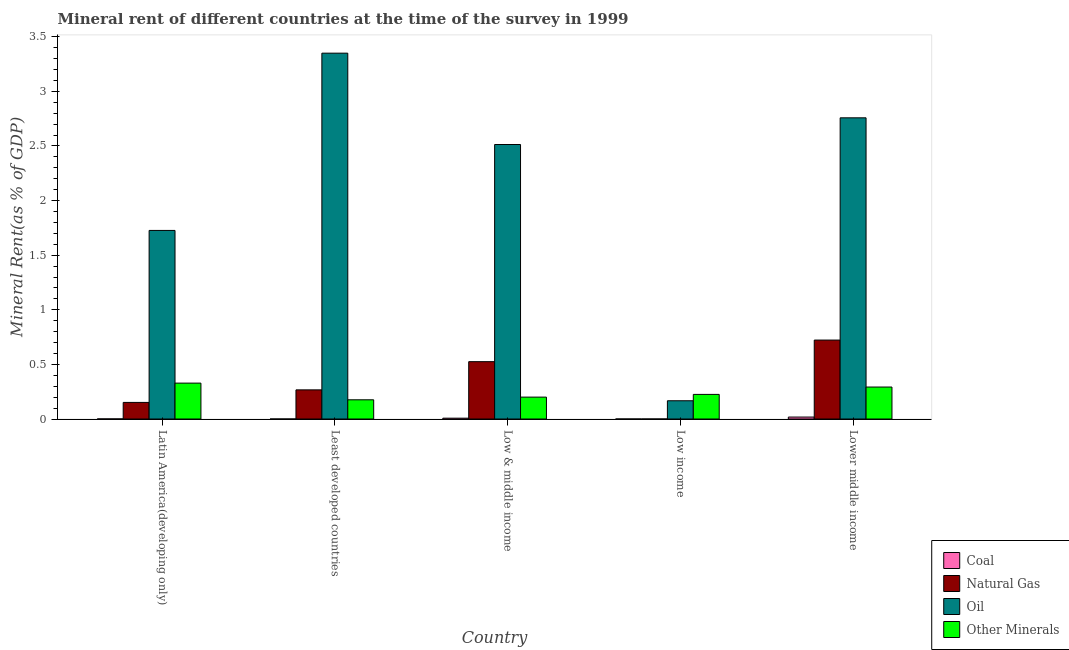How many bars are there on the 1st tick from the left?
Ensure brevity in your answer.  4. How many bars are there on the 4th tick from the right?
Offer a very short reply. 4. What is the label of the 1st group of bars from the left?
Keep it short and to the point. Latin America(developing only). What is the oil rent in Latin America(developing only)?
Your answer should be compact. 1.73. Across all countries, what is the maximum oil rent?
Ensure brevity in your answer.  3.35. Across all countries, what is the minimum oil rent?
Offer a very short reply. 0.17. In which country was the oil rent maximum?
Your answer should be compact. Least developed countries. In which country was the  rent of other minerals minimum?
Offer a terse response. Least developed countries. What is the total  rent of other minerals in the graph?
Your answer should be compact. 1.22. What is the difference between the natural gas rent in Latin America(developing only) and that in Low income?
Provide a succinct answer. 0.15. What is the difference between the  rent of other minerals in Lower middle income and the natural gas rent in Low & middle income?
Provide a short and direct response. -0.23. What is the average  rent of other minerals per country?
Make the answer very short. 0.24. What is the difference between the oil rent and natural gas rent in Latin America(developing only)?
Your answer should be very brief. 1.57. What is the ratio of the coal rent in Latin America(developing only) to that in Low income?
Make the answer very short. 89.33. Is the oil rent in Latin America(developing only) less than that in Low & middle income?
Make the answer very short. Yes. Is the difference between the coal rent in Least developed countries and Low & middle income greater than the difference between the oil rent in Least developed countries and Low & middle income?
Offer a very short reply. No. What is the difference between the highest and the second highest natural gas rent?
Ensure brevity in your answer.  0.2. What is the difference between the highest and the lowest  rent of other minerals?
Provide a short and direct response. 0.15. In how many countries, is the coal rent greater than the average coal rent taken over all countries?
Provide a short and direct response. 2. Is it the case that in every country, the sum of the oil rent and coal rent is greater than the sum of  rent of other minerals and natural gas rent?
Your answer should be very brief. No. What does the 1st bar from the left in Low & middle income represents?
Your answer should be very brief. Coal. What does the 1st bar from the right in Lower middle income represents?
Your answer should be compact. Other Minerals. How many bars are there?
Provide a short and direct response. 20. Are all the bars in the graph horizontal?
Make the answer very short. No. Does the graph contain any zero values?
Provide a short and direct response. No. Does the graph contain grids?
Ensure brevity in your answer.  No. Where does the legend appear in the graph?
Give a very brief answer. Bottom right. How many legend labels are there?
Offer a terse response. 4. How are the legend labels stacked?
Your response must be concise. Vertical. What is the title of the graph?
Your answer should be compact. Mineral rent of different countries at the time of the survey in 1999. What is the label or title of the Y-axis?
Your answer should be compact. Mineral Rent(as % of GDP). What is the Mineral Rent(as % of GDP) of Coal in Latin America(developing only)?
Offer a terse response. 0. What is the Mineral Rent(as % of GDP) of Natural Gas in Latin America(developing only)?
Your answer should be compact. 0.15. What is the Mineral Rent(as % of GDP) in Oil in Latin America(developing only)?
Your response must be concise. 1.73. What is the Mineral Rent(as % of GDP) of Other Minerals in Latin America(developing only)?
Provide a short and direct response. 0.33. What is the Mineral Rent(as % of GDP) in Coal in Least developed countries?
Provide a short and direct response. 1.688733010769859e-5. What is the Mineral Rent(as % of GDP) in Natural Gas in Least developed countries?
Offer a very short reply. 0.27. What is the Mineral Rent(as % of GDP) of Oil in Least developed countries?
Your response must be concise. 3.35. What is the Mineral Rent(as % of GDP) in Other Minerals in Least developed countries?
Your answer should be compact. 0.18. What is the Mineral Rent(as % of GDP) of Coal in Low & middle income?
Provide a succinct answer. 0.01. What is the Mineral Rent(as % of GDP) of Natural Gas in Low & middle income?
Keep it short and to the point. 0.53. What is the Mineral Rent(as % of GDP) in Oil in Low & middle income?
Your answer should be compact. 2.51. What is the Mineral Rent(as % of GDP) in Other Minerals in Low & middle income?
Offer a terse response. 0.2. What is the Mineral Rent(as % of GDP) in Coal in Low income?
Ensure brevity in your answer.  9.01283239610206e-6. What is the Mineral Rent(as % of GDP) of Natural Gas in Low income?
Offer a very short reply. 4.69772614176007e-5. What is the Mineral Rent(as % of GDP) in Oil in Low income?
Make the answer very short. 0.17. What is the Mineral Rent(as % of GDP) in Other Minerals in Low income?
Provide a succinct answer. 0.23. What is the Mineral Rent(as % of GDP) of Coal in Lower middle income?
Make the answer very short. 0.02. What is the Mineral Rent(as % of GDP) of Natural Gas in Lower middle income?
Ensure brevity in your answer.  0.72. What is the Mineral Rent(as % of GDP) in Oil in Lower middle income?
Your response must be concise. 2.76. What is the Mineral Rent(as % of GDP) in Other Minerals in Lower middle income?
Your response must be concise. 0.29. Across all countries, what is the maximum Mineral Rent(as % of GDP) of Coal?
Ensure brevity in your answer.  0.02. Across all countries, what is the maximum Mineral Rent(as % of GDP) of Natural Gas?
Offer a terse response. 0.72. Across all countries, what is the maximum Mineral Rent(as % of GDP) in Oil?
Your answer should be very brief. 3.35. Across all countries, what is the maximum Mineral Rent(as % of GDP) in Other Minerals?
Give a very brief answer. 0.33. Across all countries, what is the minimum Mineral Rent(as % of GDP) of Coal?
Give a very brief answer. 9.01283239610206e-6. Across all countries, what is the minimum Mineral Rent(as % of GDP) of Natural Gas?
Offer a very short reply. 4.69772614176007e-5. Across all countries, what is the minimum Mineral Rent(as % of GDP) of Oil?
Make the answer very short. 0.17. Across all countries, what is the minimum Mineral Rent(as % of GDP) in Other Minerals?
Offer a terse response. 0.18. What is the total Mineral Rent(as % of GDP) of Coal in the graph?
Keep it short and to the point. 0.03. What is the total Mineral Rent(as % of GDP) of Natural Gas in the graph?
Provide a succinct answer. 1.67. What is the total Mineral Rent(as % of GDP) of Oil in the graph?
Offer a terse response. 10.51. What is the total Mineral Rent(as % of GDP) of Other Minerals in the graph?
Your answer should be very brief. 1.22. What is the difference between the Mineral Rent(as % of GDP) in Coal in Latin America(developing only) and that in Least developed countries?
Provide a succinct answer. 0. What is the difference between the Mineral Rent(as % of GDP) in Natural Gas in Latin America(developing only) and that in Least developed countries?
Ensure brevity in your answer.  -0.11. What is the difference between the Mineral Rent(as % of GDP) in Oil in Latin America(developing only) and that in Least developed countries?
Provide a short and direct response. -1.62. What is the difference between the Mineral Rent(as % of GDP) in Other Minerals in Latin America(developing only) and that in Least developed countries?
Your response must be concise. 0.15. What is the difference between the Mineral Rent(as % of GDP) of Coal in Latin America(developing only) and that in Low & middle income?
Ensure brevity in your answer.  -0.01. What is the difference between the Mineral Rent(as % of GDP) in Natural Gas in Latin America(developing only) and that in Low & middle income?
Your response must be concise. -0.37. What is the difference between the Mineral Rent(as % of GDP) of Oil in Latin America(developing only) and that in Low & middle income?
Your answer should be very brief. -0.79. What is the difference between the Mineral Rent(as % of GDP) of Other Minerals in Latin America(developing only) and that in Low & middle income?
Offer a terse response. 0.13. What is the difference between the Mineral Rent(as % of GDP) in Coal in Latin America(developing only) and that in Low income?
Your answer should be very brief. 0. What is the difference between the Mineral Rent(as % of GDP) of Natural Gas in Latin America(developing only) and that in Low income?
Keep it short and to the point. 0.15. What is the difference between the Mineral Rent(as % of GDP) of Oil in Latin America(developing only) and that in Low income?
Make the answer very short. 1.56. What is the difference between the Mineral Rent(as % of GDP) in Other Minerals in Latin America(developing only) and that in Low income?
Offer a very short reply. 0.1. What is the difference between the Mineral Rent(as % of GDP) in Coal in Latin America(developing only) and that in Lower middle income?
Your answer should be very brief. -0.02. What is the difference between the Mineral Rent(as % of GDP) in Natural Gas in Latin America(developing only) and that in Lower middle income?
Offer a very short reply. -0.57. What is the difference between the Mineral Rent(as % of GDP) in Oil in Latin America(developing only) and that in Lower middle income?
Your response must be concise. -1.03. What is the difference between the Mineral Rent(as % of GDP) in Other Minerals in Latin America(developing only) and that in Lower middle income?
Give a very brief answer. 0.04. What is the difference between the Mineral Rent(as % of GDP) in Coal in Least developed countries and that in Low & middle income?
Keep it short and to the point. -0.01. What is the difference between the Mineral Rent(as % of GDP) in Natural Gas in Least developed countries and that in Low & middle income?
Give a very brief answer. -0.26. What is the difference between the Mineral Rent(as % of GDP) of Oil in Least developed countries and that in Low & middle income?
Provide a succinct answer. 0.84. What is the difference between the Mineral Rent(as % of GDP) of Other Minerals in Least developed countries and that in Low & middle income?
Your answer should be very brief. -0.02. What is the difference between the Mineral Rent(as % of GDP) in Natural Gas in Least developed countries and that in Low income?
Provide a succinct answer. 0.27. What is the difference between the Mineral Rent(as % of GDP) of Oil in Least developed countries and that in Low income?
Offer a terse response. 3.18. What is the difference between the Mineral Rent(as % of GDP) of Other Minerals in Least developed countries and that in Low income?
Provide a succinct answer. -0.05. What is the difference between the Mineral Rent(as % of GDP) of Coal in Least developed countries and that in Lower middle income?
Make the answer very short. -0.02. What is the difference between the Mineral Rent(as % of GDP) of Natural Gas in Least developed countries and that in Lower middle income?
Ensure brevity in your answer.  -0.46. What is the difference between the Mineral Rent(as % of GDP) in Oil in Least developed countries and that in Lower middle income?
Your response must be concise. 0.59. What is the difference between the Mineral Rent(as % of GDP) of Other Minerals in Least developed countries and that in Lower middle income?
Provide a succinct answer. -0.12. What is the difference between the Mineral Rent(as % of GDP) of Coal in Low & middle income and that in Low income?
Ensure brevity in your answer.  0.01. What is the difference between the Mineral Rent(as % of GDP) of Natural Gas in Low & middle income and that in Low income?
Give a very brief answer. 0.53. What is the difference between the Mineral Rent(as % of GDP) in Oil in Low & middle income and that in Low income?
Your answer should be compact. 2.35. What is the difference between the Mineral Rent(as % of GDP) of Other Minerals in Low & middle income and that in Low income?
Your response must be concise. -0.02. What is the difference between the Mineral Rent(as % of GDP) in Coal in Low & middle income and that in Lower middle income?
Make the answer very short. -0.01. What is the difference between the Mineral Rent(as % of GDP) in Natural Gas in Low & middle income and that in Lower middle income?
Provide a succinct answer. -0.2. What is the difference between the Mineral Rent(as % of GDP) in Oil in Low & middle income and that in Lower middle income?
Provide a short and direct response. -0.24. What is the difference between the Mineral Rent(as % of GDP) of Other Minerals in Low & middle income and that in Lower middle income?
Your response must be concise. -0.09. What is the difference between the Mineral Rent(as % of GDP) of Coal in Low income and that in Lower middle income?
Keep it short and to the point. -0.02. What is the difference between the Mineral Rent(as % of GDP) of Natural Gas in Low income and that in Lower middle income?
Ensure brevity in your answer.  -0.72. What is the difference between the Mineral Rent(as % of GDP) of Oil in Low income and that in Lower middle income?
Provide a short and direct response. -2.59. What is the difference between the Mineral Rent(as % of GDP) of Other Minerals in Low income and that in Lower middle income?
Keep it short and to the point. -0.07. What is the difference between the Mineral Rent(as % of GDP) of Coal in Latin America(developing only) and the Mineral Rent(as % of GDP) of Natural Gas in Least developed countries?
Provide a short and direct response. -0.27. What is the difference between the Mineral Rent(as % of GDP) of Coal in Latin America(developing only) and the Mineral Rent(as % of GDP) of Oil in Least developed countries?
Ensure brevity in your answer.  -3.35. What is the difference between the Mineral Rent(as % of GDP) of Coal in Latin America(developing only) and the Mineral Rent(as % of GDP) of Other Minerals in Least developed countries?
Provide a short and direct response. -0.18. What is the difference between the Mineral Rent(as % of GDP) in Natural Gas in Latin America(developing only) and the Mineral Rent(as % of GDP) in Oil in Least developed countries?
Your response must be concise. -3.2. What is the difference between the Mineral Rent(as % of GDP) in Natural Gas in Latin America(developing only) and the Mineral Rent(as % of GDP) in Other Minerals in Least developed countries?
Offer a very short reply. -0.02. What is the difference between the Mineral Rent(as % of GDP) of Oil in Latin America(developing only) and the Mineral Rent(as % of GDP) of Other Minerals in Least developed countries?
Ensure brevity in your answer.  1.55. What is the difference between the Mineral Rent(as % of GDP) in Coal in Latin America(developing only) and the Mineral Rent(as % of GDP) in Natural Gas in Low & middle income?
Keep it short and to the point. -0.52. What is the difference between the Mineral Rent(as % of GDP) of Coal in Latin America(developing only) and the Mineral Rent(as % of GDP) of Oil in Low & middle income?
Provide a succinct answer. -2.51. What is the difference between the Mineral Rent(as % of GDP) in Coal in Latin America(developing only) and the Mineral Rent(as % of GDP) in Other Minerals in Low & middle income?
Provide a succinct answer. -0.2. What is the difference between the Mineral Rent(as % of GDP) in Natural Gas in Latin America(developing only) and the Mineral Rent(as % of GDP) in Oil in Low & middle income?
Ensure brevity in your answer.  -2.36. What is the difference between the Mineral Rent(as % of GDP) in Natural Gas in Latin America(developing only) and the Mineral Rent(as % of GDP) in Other Minerals in Low & middle income?
Ensure brevity in your answer.  -0.05. What is the difference between the Mineral Rent(as % of GDP) in Oil in Latin America(developing only) and the Mineral Rent(as % of GDP) in Other Minerals in Low & middle income?
Your answer should be compact. 1.53. What is the difference between the Mineral Rent(as % of GDP) of Coal in Latin America(developing only) and the Mineral Rent(as % of GDP) of Natural Gas in Low income?
Offer a terse response. 0. What is the difference between the Mineral Rent(as % of GDP) of Coal in Latin America(developing only) and the Mineral Rent(as % of GDP) of Oil in Low income?
Make the answer very short. -0.17. What is the difference between the Mineral Rent(as % of GDP) of Coal in Latin America(developing only) and the Mineral Rent(as % of GDP) of Other Minerals in Low income?
Offer a terse response. -0.22. What is the difference between the Mineral Rent(as % of GDP) in Natural Gas in Latin America(developing only) and the Mineral Rent(as % of GDP) in Oil in Low income?
Ensure brevity in your answer.  -0.02. What is the difference between the Mineral Rent(as % of GDP) in Natural Gas in Latin America(developing only) and the Mineral Rent(as % of GDP) in Other Minerals in Low income?
Your response must be concise. -0.07. What is the difference between the Mineral Rent(as % of GDP) in Oil in Latin America(developing only) and the Mineral Rent(as % of GDP) in Other Minerals in Low income?
Offer a terse response. 1.5. What is the difference between the Mineral Rent(as % of GDP) of Coal in Latin America(developing only) and the Mineral Rent(as % of GDP) of Natural Gas in Lower middle income?
Provide a short and direct response. -0.72. What is the difference between the Mineral Rent(as % of GDP) in Coal in Latin America(developing only) and the Mineral Rent(as % of GDP) in Oil in Lower middle income?
Ensure brevity in your answer.  -2.76. What is the difference between the Mineral Rent(as % of GDP) in Coal in Latin America(developing only) and the Mineral Rent(as % of GDP) in Other Minerals in Lower middle income?
Make the answer very short. -0.29. What is the difference between the Mineral Rent(as % of GDP) of Natural Gas in Latin America(developing only) and the Mineral Rent(as % of GDP) of Oil in Lower middle income?
Offer a terse response. -2.61. What is the difference between the Mineral Rent(as % of GDP) in Natural Gas in Latin America(developing only) and the Mineral Rent(as % of GDP) in Other Minerals in Lower middle income?
Offer a very short reply. -0.14. What is the difference between the Mineral Rent(as % of GDP) of Oil in Latin America(developing only) and the Mineral Rent(as % of GDP) of Other Minerals in Lower middle income?
Give a very brief answer. 1.43. What is the difference between the Mineral Rent(as % of GDP) in Coal in Least developed countries and the Mineral Rent(as % of GDP) in Natural Gas in Low & middle income?
Offer a terse response. -0.53. What is the difference between the Mineral Rent(as % of GDP) of Coal in Least developed countries and the Mineral Rent(as % of GDP) of Oil in Low & middle income?
Your answer should be compact. -2.51. What is the difference between the Mineral Rent(as % of GDP) of Coal in Least developed countries and the Mineral Rent(as % of GDP) of Other Minerals in Low & middle income?
Your answer should be compact. -0.2. What is the difference between the Mineral Rent(as % of GDP) in Natural Gas in Least developed countries and the Mineral Rent(as % of GDP) in Oil in Low & middle income?
Provide a short and direct response. -2.25. What is the difference between the Mineral Rent(as % of GDP) in Natural Gas in Least developed countries and the Mineral Rent(as % of GDP) in Other Minerals in Low & middle income?
Your answer should be very brief. 0.07. What is the difference between the Mineral Rent(as % of GDP) in Oil in Least developed countries and the Mineral Rent(as % of GDP) in Other Minerals in Low & middle income?
Ensure brevity in your answer.  3.15. What is the difference between the Mineral Rent(as % of GDP) of Coal in Least developed countries and the Mineral Rent(as % of GDP) of Oil in Low income?
Provide a succinct answer. -0.17. What is the difference between the Mineral Rent(as % of GDP) in Coal in Least developed countries and the Mineral Rent(as % of GDP) in Other Minerals in Low income?
Keep it short and to the point. -0.23. What is the difference between the Mineral Rent(as % of GDP) in Natural Gas in Least developed countries and the Mineral Rent(as % of GDP) in Oil in Low income?
Ensure brevity in your answer.  0.1. What is the difference between the Mineral Rent(as % of GDP) of Natural Gas in Least developed countries and the Mineral Rent(as % of GDP) of Other Minerals in Low income?
Offer a very short reply. 0.04. What is the difference between the Mineral Rent(as % of GDP) in Oil in Least developed countries and the Mineral Rent(as % of GDP) in Other Minerals in Low income?
Keep it short and to the point. 3.12. What is the difference between the Mineral Rent(as % of GDP) of Coal in Least developed countries and the Mineral Rent(as % of GDP) of Natural Gas in Lower middle income?
Keep it short and to the point. -0.72. What is the difference between the Mineral Rent(as % of GDP) in Coal in Least developed countries and the Mineral Rent(as % of GDP) in Oil in Lower middle income?
Keep it short and to the point. -2.76. What is the difference between the Mineral Rent(as % of GDP) of Coal in Least developed countries and the Mineral Rent(as % of GDP) of Other Minerals in Lower middle income?
Your answer should be very brief. -0.29. What is the difference between the Mineral Rent(as % of GDP) of Natural Gas in Least developed countries and the Mineral Rent(as % of GDP) of Oil in Lower middle income?
Give a very brief answer. -2.49. What is the difference between the Mineral Rent(as % of GDP) in Natural Gas in Least developed countries and the Mineral Rent(as % of GDP) in Other Minerals in Lower middle income?
Make the answer very short. -0.03. What is the difference between the Mineral Rent(as % of GDP) of Oil in Least developed countries and the Mineral Rent(as % of GDP) of Other Minerals in Lower middle income?
Your response must be concise. 3.06. What is the difference between the Mineral Rent(as % of GDP) in Coal in Low & middle income and the Mineral Rent(as % of GDP) in Natural Gas in Low income?
Give a very brief answer. 0.01. What is the difference between the Mineral Rent(as % of GDP) of Coal in Low & middle income and the Mineral Rent(as % of GDP) of Oil in Low income?
Your answer should be very brief. -0.16. What is the difference between the Mineral Rent(as % of GDP) in Coal in Low & middle income and the Mineral Rent(as % of GDP) in Other Minerals in Low income?
Your response must be concise. -0.22. What is the difference between the Mineral Rent(as % of GDP) of Natural Gas in Low & middle income and the Mineral Rent(as % of GDP) of Oil in Low income?
Give a very brief answer. 0.36. What is the difference between the Mineral Rent(as % of GDP) of Natural Gas in Low & middle income and the Mineral Rent(as % of GDP) of Other Minerals in Low income?
Offer a terse response. 0.3. What is the difference between the Mineral Rent(as % of GDP) of Oil in Low & middle income and the Mineral Rent(as % of GDP) of Other Minerals in Low income?
Provide a short and direct response. 2.29. What is the difference between the Mineral Rent(as % of GDP) of Coal in Low & middle income and the Mineral Rent(as % of GDP) of Natural Gas in Lower middle income?
Give a very brief answer. -0.72. What is the difference between the Mineral Rent(as % of GDP) of Coal in Low & middle income and the Mineral Rent(as % of GDP) of Oil in Lower middle income?
Your response must be concise. -2.75. What is the difference between the Mineral Rent(as % of GDP) of Coal in Low & middle income and the Mineral Rent(as % of GDP) of Other Minerals in Lower middle income?
Your response must be concise. -0.29. What is the difference between the Mineral Rent(as % of GDP) in Natural Gas in Low & middle income and the Mineral Rent(as % of GDP) in Oil in Lower middle income?
Offer a very short reply. -2.23. What is the difference between the Mineral Rent(as % of GDP) in Natural Gas in Low & middle income and the Mineral Rent(as % of GDP) in Other Minerals in Lower middle income?
Ensure brevity in your answer.  0.23. What is the difference between the Mineral Rent(as % of GDP) of Oil in Low & middle income and the Mineral Rent(as % of GDP) of Other Minerals in Lower middle income?
Provide a succinct answer. 2.22. What is the difference between the Mineral Rent(as % of GDP) in Coal in Low income and the Mineral Rent(as % of GDP) in Natural Gas in Lower middle income?
Your response must be concise. -0.72. What is the difference between the Mineral Rent(as % of GDP) of Coal in Low income and the Mineral Rent(as % of GDP) of Oil in Lower middle income?
Offer a terse response. -2.76. What is the difference between the Mineral Rent(as % of GDP) of Coal in Low income and the Mineral Rent(as % of GDP) of Other Minerals in Lower middle income?
Offer a very short reply. -0.29. What is the difference between the Mineral Rent(as % of GDP) of Natural Gas in Low income and the Mineral Rent(as % of GDP) of Oil in Lower middle income?
Give a very brief answer. -2.76. What is the difference between the Mineral Rent(as % of GDP) of Natural Gas in Low income and the Mineral Rent(as % of GDP) of Other Minerals in Lower middle income?
Offer a terse response. -0.29. What is the difference between the Mineral Rent(as % of GDP) in Oil in Low income and the Mineral Rent(as % of GDP) in Other Minerals in Lower middle income?
Your answer should be very brief. -0.13. What is the average Mineral Rent(as % of GDP) of Coal per country?
Your answer should be very brief. 0.01. What is the average Mineral Rent(as % of GDP) of Natural Gas per country?
Provide a succinct answer. 0.33. What is the average Mineral Rent(as % of GDP) of Oil per country?
Ensure brevity in your answer.  2.1. What is the average Mineral Rent(as % of GDP) of Other Minerals per country?
Give a very brief answer. 0.24. What is the difference between the Mineral Rent(as % of GDP) in Coal and Mineral Rent(as % of GDP) in Natural Gas in Latin America(developing only)?
Make the answer very short. -0.15. What is the difference between the Mineral Rent(as % of GDP) in Coal and Mineral Rent(as % of GDP) in Oil in Latin America(developing only)?
Your answer should be compact. -1.73. What is the difference between the Mineral Rent(as % of GDP) in Coal and Mineral Rent(as % of GDP) in Other Minerals in Latin America(developing only)?
Ensure brevity in your answer.  -0.33. What is the difference between the Mineral Rent(as % of GDP) in Natural Gas and Mineral Rent(as % of GDP) in Oil in Latin America(developing only)?
Offer a terse response. -1.57. What is the difference between the Mineral Rent(as % of GDP) in Natural Gas and Mineral Rent(as % of GDP) in Other Minerals in Latin America(developing only)?
Keep it short and to the point. -0.18. What is the difference between the Mineral Rent(as % of GDP) in Oil and Mineral Rent(as % of GDP) in Other Minerals in Latin America(developing only)?
Keep it short and to the point. 1.4. What is the difference between the Mineral Rent(as % of GDP) of Coal and Mineral Rent(as % of GDP) of Natural Gas in Least developed countries?
Keep it short and to the point. -0.27. What is the difference between the Mineral Rent(as % of GDP) of Coal and Mineral Rent(as % of GDP) of Oil in Least developed countries?
Your answer should be compact. -3.35. What is the difference between the Mineral Rent(as % of GDP) in Coal and Mineral Rent(as % of GDP) in Other Minerals in Least developed countries?
Provide a succinct answer. -0.18. What is the difference between the Mineral Rent(as % of GDP) of Natural Gas and Mineral Rent(as % of GDP) of Oil in Least developed countries?
Provide a short and direct response. -3.08. What is the difference between the Mineral Rent(as % of GDP) in Natural Gas and Mineral Rent(as % of GDP) in Other Minerals in Least developed countries?
Offer a very short reply. 0.09. What is the difference between the Mineral Rent(as % of GDP) in Oil and Mineral Rent(as % of GDP) in Other Minerals in Least developed countries?
Offer a very short reply. 3.17. What is the difference between the Mineral Rent(as % of GDP) in Coal and Mineral Rent(as % of GDP) in Natural Gas in Low & middle income?
Offer a very short reply. -0.52. What is the difference between the Mineral Rent(as % of GDP) of Coal and Mineral Rent(as % of GDP) of Oil in Low & middle income?
Ensure brevity in your answer.  -2.51. What is the difference between the Mineral Rent(as % of GDP) in Coal and Mineral Rent(as % of GDP) in Other Minerals in Low & middle income?
Your answer should be very brief. -0.19. What is the difference between the Mineral Rent(as % of GDP) in Natural Gas and Mineral Rent(as % of GDP) in Oil in Low & middle income?
Your answer should be very brief. -1.99. What is the difference between the Mineral Rent(as % of GDP) in Natural Gas and Mineral Rent(as % of GDP) in Other Minerals in Low & middle income?
Your answer should be compact. 0.32. What is the difference between the Mineral Rent(as % of GDP) of Oil and Mineral Rent(as % of GDP) of Other Minerals in Low & middle income?
Your answer should be very brief. 2.31. What is the difference between the Mineral Rent(as % of GDP) of Coal and Mineral Rent(as % of GDP) of Oil in Low income?
Make the answer very short. -0.17. What is the difference between the Mineral Rent(as % of GDP) of Coal and Mineral Rent(as % of GDP) of Other Minerals in Low income?
Ensure brevity in your answer.  -0.23. What is the difference between the Mineral Rent(as % of GDP) of Natural Gas and Mineral Rent(as % of GDP) of Oil in Low income?
Provide a short and direct response. -0.17. What is the difference between the Mineral Rent(as % of GDP) of Natural Gas and Mineral Rent(as % of GDP) of Other Minerals in Low income?
Provide a short and direct response. -0.23. What is the difference between the Mineral Rent(as % of GDP) of Oil and Mineral Rent(as % of GDP) of Other Minerals in Low income?
Your response must be concise. -0.06. What is the difference between the Mineral Rent(as % of GDP) in Coal and Mineral Rent(as % of GDP) in Natural Gas in Lower middle income?
Give a very brief answer. -0.7. What is the difference between the Mineral Rent(as % of GDP) of Coal and Mineral Rent(as % of GDP) of Oil in Lower middle income?
Your response must be concise. -2.74. What is the difference between the Mineral Rent(as % of GDP) in Coal and Mineral Rent(as % of GDP) in Other Minerals in Lower middle income?
Your answer should be compact. -0.27. What is the difference between the Mineral Rent(as % of GDP) in Natural Gas and Mineral Rent(as % of GDP) in Oil in Lower middle income?
Offer a very short reply. -2.03. What is the difference between the Mineral Rent(as % of GDP) of Natural Gas and Mineral Rent(as % of GDP) of Other Minerals in Lower middle income?
Your answer should be very brief. 0.43. What is the difference between the Mineral Rent(as % of GDP) of Oil and Mineral Rent(as % of GDP) of Other Minerals in Lower middle income?
Ensure brevity in your answer.  2.46. What is the ratio of the Mineral Rent(as % of GDP) of Coal in Latin America(developing only) to that in Least developed countries?
Your answer should be compact. 47.68. What is the ratio of the Mineral Rent(as % of GDP) in Natural Gas in Latin America(developing only) to that in Least developed countries?
Offer a very short reply. 0.57. What is the ratio of the Mineral Rent(as % of GDP) in Oil in Latin America(developing only) to that in Least developed countries?
Provide a short and direct response. 0.52. What is the ratio of the Mineral Rent(as % of GDP) of Other Minerals in Latin America(developing only) to that in Least developed countries?
Give a very brief answer. 1.87. What is the ratio of the Mineral Rent(as % of GDP) of Coal in Latin America(developing only) to that in Low & middle income?
Offer a terse response. 0.11. What is the ratio of the Mineral Rent(as % of GDP) in Natural Gas in Latin America(developing only) to that in Low & middle income?
Ensure brevity in your answer.  0.29. What is the ratio of the Mineral Rent(as % of GDP) of Oil in Latin America(developing only) to that in Low & middle income?
Offer a terse response. 0.69. What is the ratio of the Mineral Rent(as % of GDP) in Other Minerals in Latin America(developing only) to that in Low & middle income?
Offer a very short reply. 1.64. What is the ratio of the Mineral Rent(as % of GDP) in Coal in Latin America(developing only) to that in Low income?
Offer a terse response. 89.33. What is the ratio of the Mineral Rent(as % of GDP) of Natural Gas in Latin America(developing only) to that in Low income?
Offer a terse response. 3236.3. What is the ratio of the Mineral Rent(as % of GDP) in Oil in Latin America(developing only) to that in Low income?
Offer a terse response. 10.33. What is the ratio of the Mineral Rent(as % of GDP) of Other Minerals in Latin America(developing only) to that in Low income?
Ensure brevity in your answer.  1.46. What is the ratio of the Mineral Rent(as % of GDP) of Coal in Latin America(developing only) to that in Lower middle income?
Make the answer very short. 0.04. What is the ratio of the Mineral Rent(as % of GDP) of Natural Gas in Latin America(developing only) to that in Lower middle income?
Keep it short and to the point. 0.21. What is the ratio of the Mineral Rent(as % of GDP) of Oil in Latin America(developing only) to that in Lower middle income?
Your response must be concise. 0.63. What is the ratio of the Mineral Rent(as % of GDP) of Other Minerals in Latin America(developing only) to that in Lower middle income?
Give a very brief answer. 1.12. What is the ratio of the Mineral Rent(as % of GDP) of Coal in Least developed countries to that in Low & middle income?
Provide a succinct answer. 0. What is the ratio of the Mineral Rent(as % of GDP) of Natural Gas in Least developed countries to that in Low & middle income?
Make the answer very short. 0.51. What is the ratio of the Mineral Rent(as % of GDP) of Oil in Least developed countries to that in Low & middle income?
Give a very brief answer. 1.33. What is the ratio of the Mineral Rent(as % of GDP) of Other Minerals in Least developed countries to that in Low & middle income?
Ensure brevity in your answer.  0.88. What is the ratio of the Mineral Rent(as % of GDP) of Coal in Least developed countries to that in Low income?
Provide a succinct answer. 1.87. What is the ratio of the Mineral Rent(as % of GDP) in Natural Gas in Least developed countries to that in Low income?
Your response must be concise. 5679.92. What is the ratio of the Mineral Rent(as % of GDP) of Oil in Least developed countries to that in Low income?
Offer a terse response. 20.05. What is the ratio of the Mineral Rent(as % of GDP) in Other Minerals in Least developed countries to that in Low income?
Your response must be concise. 0.78. What is the ratio of the Mineral Rent(as % of GDP) of Coal in Least developed countries to that in Lower middle income?
Your answer should be very brief. 0. What is the ratio of the Mineral Rent(as % of GDP) in Natural Gas in Least developed countries to that in Lower middle income?
Ensure brevity in your answer.  0.37. What is the ratio of the Mineral Rent(as % of GDP) in Oil in Least developed countries to that in Lower middle income?
Provide a short and direct response. 1.21. What is the ratio of the Mineral Rent(as % of GDP) of Other Minerals in Least developed countries to that in Lower middle income?
Your response must be concise. 0.6. What is the ratio of the Mineral Rent(as % of GDP) of Coal in Low & middle income to that in Low income?
Give a very brief answer. 845.38. What is the ratio of the Mineral Rent(as % of GDP) of Natural Gas in Low & middle income to that in Low income?
Provide a short and direct response. 1.12e+04. What is the ratio of the Mineral Rent(as % of GDP) in Oil in Low & middle income to that in Low income?
Your response must be concise. 15.04. What is the ratio of the Mineral Rent(as % of GDP) of Other Minerals in Low & middle income to that in Low income?
Give a very brief answer. 0.89. What is the ratio of the Mineral Rent(as % of GDP) of Coal in Low & middle income to that in Lower middle income?
Provide a succinct answer. 0.42. What is the ratio of the Mineral Rent(as % of GDP) of Natural Gas in Low & middle income to that in Lower middle income?
Keep it short and to the point. 0.73. What is the ratio of the Mineral Rent(as % of GDP) of Oil in Low & middle income to that in Lower middle income?
Your answer should be very brief. 0.91. What is the ratio of the Mineral Rent(as % of GDP) in Other Minerals in Low & middle income to that in Lower middle income?
Offer a very short reply. 0.68. What is the ratio of the Mineral Rent(as % of GDP) of Coal in Low income to that in Lower middle income?
Offer a terse response. 0. What is the ratio of the Mineral Rent(as % of GDP) in Oil in Low income to that in Lower middle income?
Provide a short and direct response. 0.06. What is the ratio of the Mineral Rent(as % of GDP) in Other Minerals in Low income to that in Lower middle income?
Offer a terse response. 0.77. What is the difference between the highest and the second highest Mineral Rent(as % of GDP) in Coal?
Provide a short and direct response. 0.01. What is the difference between the highest and the second highest Mineral Rent(as % of GDP) of Natural Gas?
Make the answer very short. 0.2. What is the difference between the highest and the second highest Mineral Rent(as % of GDP) of Oil?
Your answer should be very brief. 0.59. What is the difference between the highest and the second highest Mineral Rent(as % of GDP) of Other Minerals?
Keep it short and to the point. 0.04. What is the difference between the highest and the lowest Mineral Rent(as % of GDP) of Coal?
Offer a very short reply. 0.02. What is the difference between the highest and the lowest Mineral Rent(as % of GDP) of Natural Gas?
Make the answer very short. 0.72. What is the difference between the highest and the lowest Mineral Rent(as % of GDP) in Oil?
Offer a very short reply. 3.18. What is the difference between the highest and the lowest Mineral Rent(as % of GDP) of Other Minerals?
Keep it short and to the point. 0.15. 